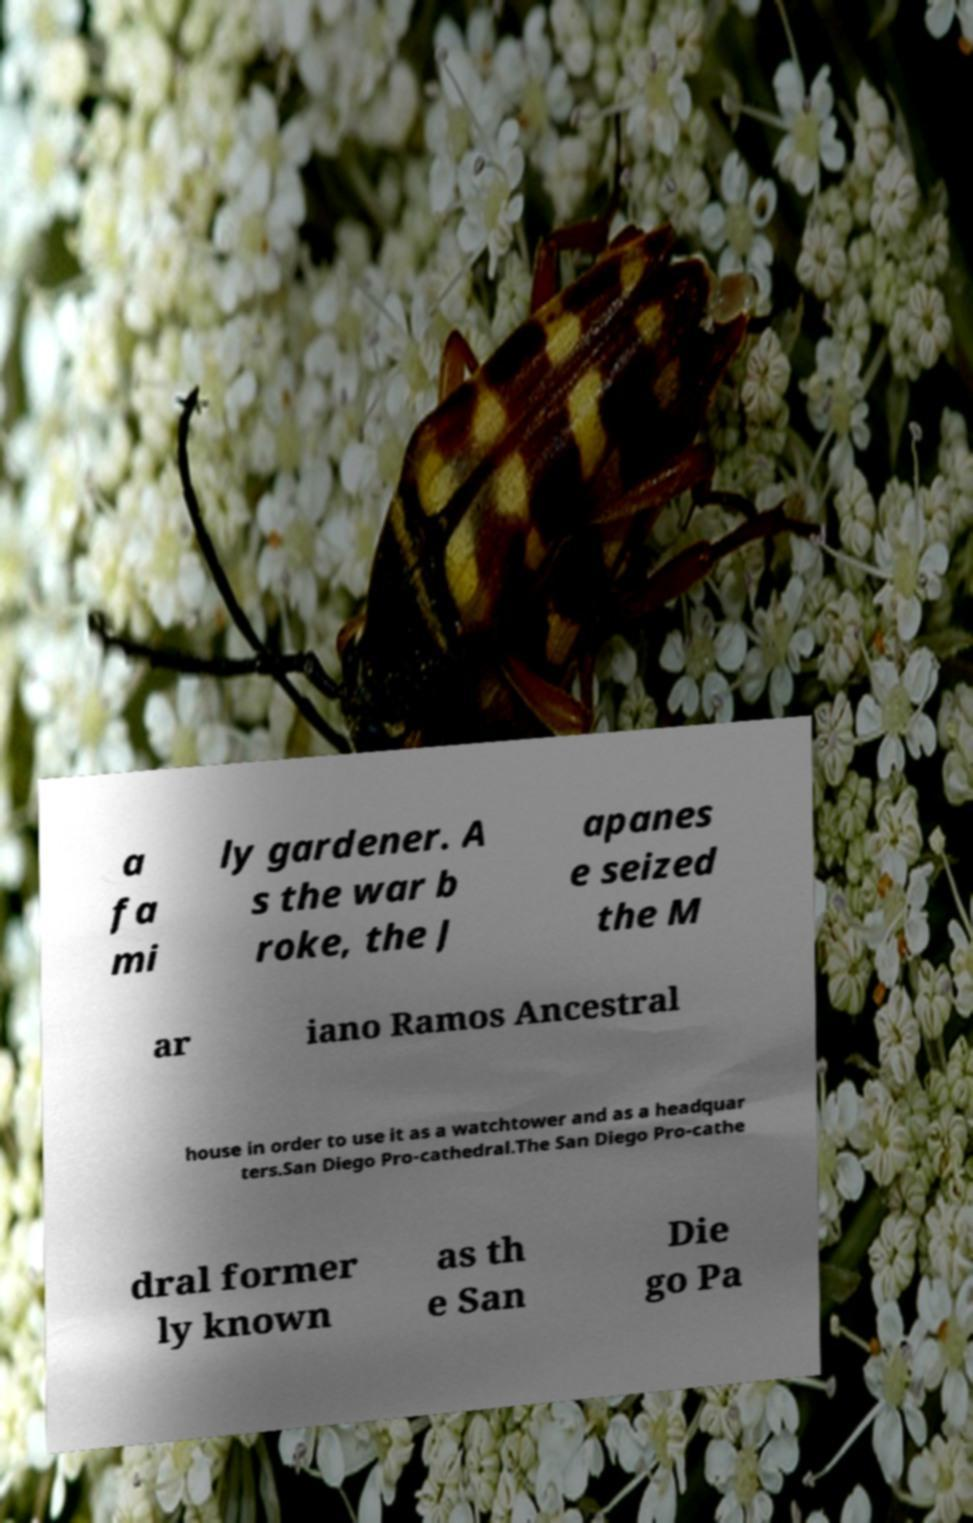What messages or text are displayed in this image? I need them in a readable, typed format. a fa mi ly gardener. A s the war b roke, the J apanes e seized the M ar iano Ramos Ancestral house in order to use it as a watchtower and as a headquar ters.San Diego Pro-cathedral.The San Diego Pro-cathe dral former ly known as th e San Die go Pa 